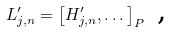Convert formula to latex. <formula><loc_0><loc_0><loc_500><loc_500>L _ { j , n } ^ { \prime } = \left [ H _ { j , n } ^ { \prime } , \dots \right ] _ { P } \text { ,}</formula> 